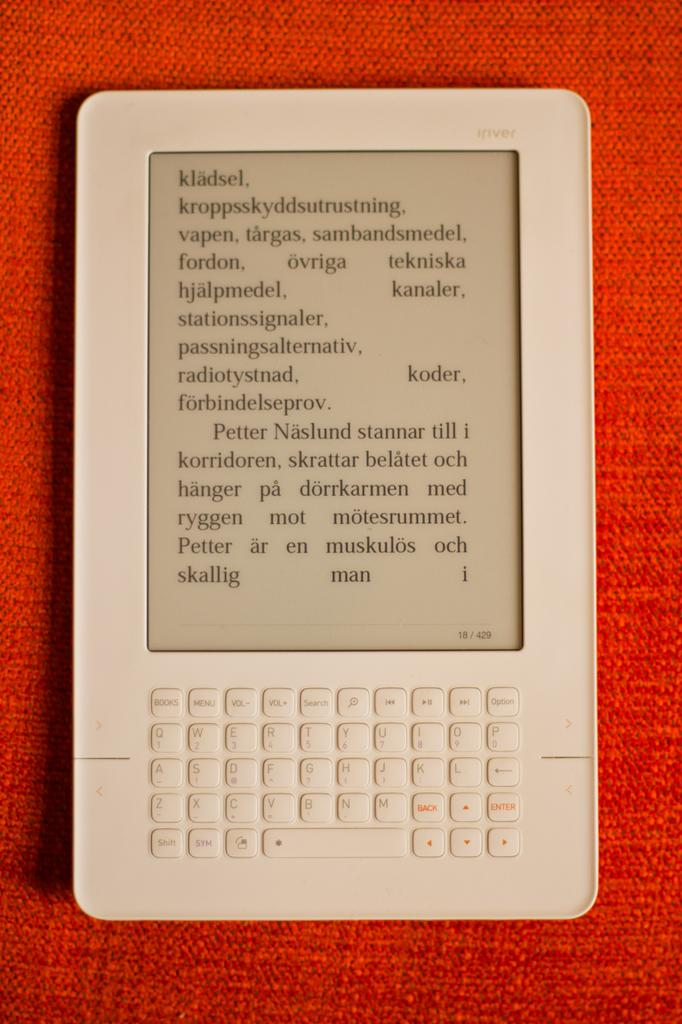<image>
Describe the image concisely. A tablet displaying some text in a foreign language. 